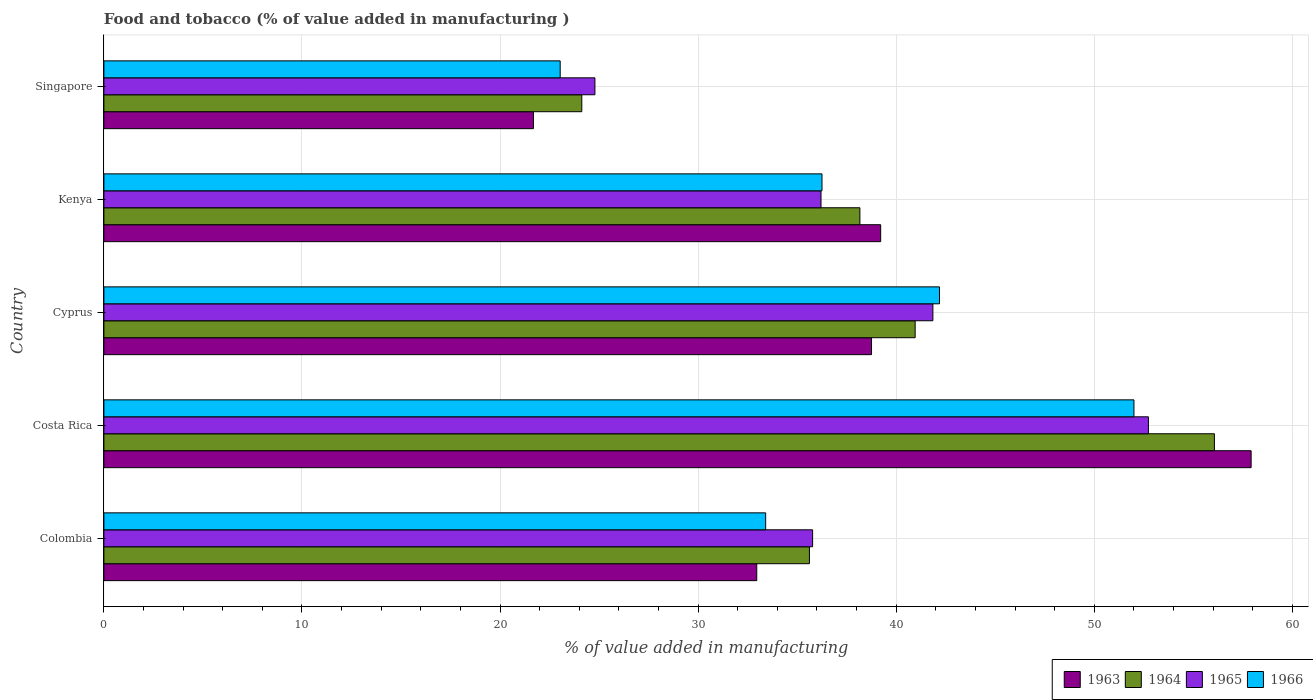How many bars are there on the 1st tick from the bottom?
Make the answer very short. 4. What is the label of the 2nd group of bars from the top?
Offer a terse response. Kenya. What is the value added in manufacturing food and tobacco in 1963 in Costa Rica?
Provide a succinct answer. 57.92. Across all countries, what is the maximum value added in manufacturing food and tobacco in 1964?
Provide a succinct answer. 56.07. Across all countries, what is the minimum value added in manufacturing food and tobacco in 1964?
Offer a very short reply. 24.13. In which country was the value added in manufacturing food and tobacco in 1963 minimum?
Your response must be concise. Singapore. What is the total value added in manufacturing food and tobacco in 1966 in the graph?
Ensure brevity in your answer.  186.89. What is the difference between the value added in manufacturing food and tobacco in 1963 in Cyprus and that in Kenya?
Provide a succinct answer. -0.46. What is the difference between the value added in manufacturing food and tobacco in 1966 in Colombia and the value added in manufacturing food and tobacco in 1963 in Kenya?
Provide a short and direct response. -5.81. What is the average value added in manufacturing food and tobacco in 1966 per country?
Provide a short and direct response. 37.38. What is the difference between the value added in manufacturing food and tobacco in 1966 and value added in manufacturing food and tobacco in 1965 in Colombia?
Offer a terse response. -2.37. What is the ratio of the value added in manufacturing food and tobacco in 1965 in Colombia to that in Singapore?
Your answer should be compact. 1.44. Is the value added in manufacturing food and tobacco in 1965 in Costa Rica less than that in Singapore?
Ensure brevity in your answer.  No. Is the difference between the value added in manufacturing food and tobacco in 1966 in Colombia and Kenya greater than the difference between the value added in manufacturing food and tobacco in 1965 in Colombia and Kenya?
Keep it short and to the point. No. What is the difference between the highest and the second highest value added in manufacturing food and tobacco in 1964?
Provide a succinct answer. 15.11. What is the difference between the highest and the lowest value added in manufacturing food and tobacco in 1963?
Offer a terse response. 36.23. In how many countries, is the value added in manufacturing food and tobacco in 1964 greater than the average value added in manufacturing food and tobacco in 1964 taken over all countries?
Your answer should be very brief. 2. Is the sum of the value added in manufacturing food and tobacco in 1963 in Colombia and Costa Rica greater than the maximum value added in manufacturing food and tobacco in 1964 across all countries?
Give a very brief answer. Yes. What does the 1st bar from the top in Colombia represents?
Make the answer very short. 1966. What does the 4th bar from the bottom in Kenya represents?
Offer a very short reply. 1966. Is it the case that in every country, the sum of the value added in manufacturing food and tobacco in 1965 and value added in manufacturing food and tobacco in 1966 is greater than the value added in manufacturing food and tobacco in 1963?
Keep it short and to the point. Yes. How many countries are there in the graph?
Ensure brevity in your answer.  5. What is the difference between two consecutive major ticks on the X-axis?
Offer a terse response. 10. Are the values on the major ticks of X-axis written in scientific E-notation?
Make the answer very short. No. Where does the legend appear in the graph?
Offer a terse response. Bottom right. How are the legend labels stacked?
Offer a very short reply. Horizontal. What is the title of the graph?
Keep it short and to the point. Food and tobacco (% of value added in manufacturing ). Does "1986" appear as one of the legend labels in the graph?
Provide a succinct answer. No. What is the label or title of the X-axis?
Your answer should be very brief. % of value added in manufacturing. What is the % of value added in manufacturing of 1963 in Colombia?
Make the answer very short. 32.96. What is the % of value added in manufacturing in 1964 in Colombia?
Provide a short and direct response. 35.62. What is the % of value added in manufacturing in 1965 in Colombia?
Your answer should be compact. 35.78. What is the % of value added in manufacturing in 1966 in Colombia?
Keep it short and to the point. 33.41. What is the % of value added in manufacturing in 1963 in Costa Rica?
Your response must be concise. 57.92. What is the % of value added in manufacturing of 1964 in Costa Rica?
Keep it short and to the point. 56.07. What is the % of value added in manufacturing in 1965 in Costa Rica?
Offer a very short reply. 52.73. What is the % of value added in manufacturing in 1966 in Costa Rica?
Keep it short and to the point. 52. What is the % of value added in manufacturing in 1963 in Cyprus?
Offer a terse response. 38.75. What is the % of value added in manufacturing in 1964 in Cyprus?
Your answer should be very brief. 40.96. What is the % of value added in manufacturing of 1965 in Cyprus?
Give a very brief answer. 41.85. What is the % of value added in manufacturing in 1966 in Cyprus?
Offer a very short reply. 42.19. What is the % of value added in manufacturing in 1963 in Kenya?
Offer a very short reply. 39.22. What is the % of value added in manufacturing of 1964 in Kenya?
Give a very brief answer. 38.17. What is the % of value added in manufacturing of 1965 in Kenya?
Ensure brevity in your answer.  36.2. What is the % of value added in manufacturing in 1966 in Kenya?
Keep it short and to the point. 36.25. What is the % of value added in manufacturing in 1963 in Singapore?
Offer a terse response. 21.69. What is the % of value added in manufacturing in 1964 in Singapore?
Your answer should be very brief. 24.13. What is the % of value added in manufacturing of 1965 in Singapore?
Give a very brief answer. 24.79. What is the % of value added in manufacturing of 1966 in Singapore?
Provide a succinct answer. 23.04. Across all countries, what is the maximum % of value added in manufacturing of 1963?
Your response must be concise. 57.92. Across all countries, what is the maximum % of value added in manufacturing in 1964?
Offer a very short reply. 56.07. Across all countries, what is the maximum % of value added in manufacturing of 1965?
Offer a very short reply. 52.73. Across all countries, what is the maximum % of value added in manufacturing in 1966?
Provide a short and direct response. 52. Across all countries, what is the minimum % of value added in manufacturing of 1963?
Give a very brief answer. 21.69. Across all countries, what is the minimum % of value added in manufacturing in 1964?
Give a very brief answer. 24.13. Across all countries, what is the minimum % of value added in manufacturing in 1965?
Your response must be concise. 24.79. Across all countries, what is the minimum % of value added in manufacturing in 1966?
Ensure brevity in your answer.  23.04. What is the total % of value added in manufacturing in 1963 in the graph?
Your answer should be compact. 190.54. What is the total % of value added in manufacturing in 1964 in the graph?
Your response must be concise. 194.94. What is the total % of value added in manufacturing of 1965 in the graph?
Offer a very short reply. 191.36. What is the total % of value added in manufacturing in 1966 in the graph?
Ensure brevity in your answer.  186.89. What is the difference between the % of value added in manufacturing of 1963 in Colombia and that in Costa Rica?
Ensure brevity in your answer.  -24.96. What is the difference between the % of value added in manufacturing in 1964 in Colombia and that in Costa Rica?
Make the answer very short. -20.45. What is the difference between the % of value added in manufacturing in 1965 in Colombia and that in Costa Rica?
Offer a terse response. -16.95. What is the difference between the % of value added in manufacturing in 1966 in Colombia and that in Costa Rica?
Your response must be concise. -18.59. What is the difference between the % of value added in manufacturing in 1963 in Colombia and that in Cyprus?
Your response must be concise. -5.79. What is the difference between the % of value added in manufacturing of 1964 in Colombia and that in Cyprus?
Keep it short and to the point. -5.34. What is the difference between the % of value added in manufacturing of 1965 in Colombia and that in Cyprus?
Provide a short and direct response. -6.07. What is the difference between the % of value added in manufacturing in 1966 in Colombia and that in Cyprus?
Give a very brief answer. -8.78. What is the difference between the % of value added in manufacturing of 1963 in Colombia and that in Kenya?
Give a very brief answer. -6.26. What is the difference between the % of value added in manufacturing of 1964 in Colombia and that in Kenya?
Make the answer very short. -2.55. What is the difference between the % of value added in manufacturing in 1965 in Colombia and that in Kenya?
Give a very brief answer. -0.42. What is the difference between the % of value added in manufacturing in 1966 in Colombia and that in Kenya?
Provide a succinct answer. -2.84. What is the difference between the % of value added in manufacturing of 1963 in Colombia and that in Singapore?
Provide a succinct answer. 11.27. What is the difference between the % of value added in manufacturing of 1964 in Colombia and that in Singapore?
Make the answer very short. 11.49. What is the difference between the % of value added in manufacturing in 1965 in Colombia and that in Singapore?
Provide a succinct answer. 10.99. What is the difference between the % of value added in manufacturing in 1966 in Colombia and that in Singapore?
Your response must be concise. 10.37. What is the difference between the % of value added in manufacturing of 1963 in Costa Rica and that in Cyprus?
Offer a very short reply. 19.17. What is the difference between the % of value added in manufacturing of 1964 in Costa Rica and that in Cyprus?
Give a very brief answer. 15.11. What is the difference between the % of value added in manufacturing in 1965 in Costa Rica and that in Cyprus?
Give a very brief answer. 10.88. What is the difference between the % of value added in manufacturing of 1966 in Costa Rica and that in Cyprus?
Provide a short and direct response. 9.82. What is the difference between the % of value added in manufacturing of 1963 in Costa Rica and that in Kenya?
Your response must be concise. 18.7. What is the difference between the % of value added in manufacturing of 1964 in Costa Rica and that in Kenya?
Your response must be concise. 17.9. What is the difference between the % of value added in manufacturing of 1965 in Costa Rica and that in Kenya?
Offer a terse response. 16.53. What is the difference between the % of value added in manufacturing in 1966 in Costa Rica and that in Kenya?
Keep it short and to the point. 15.75. What is the difference between the % of value added in manufacturing in 1963 in Costa Rica and that in Singapore?
Your answer should be compact. 36.23. What is the difference between the % of value added in manufacturing of 1964 in Costa Rica and that in Singapore?
Make the answer very short. 31.94. What is the difference between the % of value added in manufacturing of 1965 in Costa Rica and that in Singapore?
Your answer should be very brief. 27.94. What is the difference between the % of value added in manufacturing in 1966 in Costa Rica and that in Singapore?
Make the answer very short. 28.97. What is the difference between the % of value added in manufacturing in 1963 in Cyprus and that in Kenya?
Your response must be concise. -0.46. What is the difference between the % of value added in manufacturing of 1964 in Cyprus and that in Kenya?
Your answer should be very brief. 2.79. What is the difference between the % of value added in manufacturing of 1965 in Cyprus and that in Kenya?
Give a very brief answer. 5.65. What is the difference between the % of value added in manufacturing in 1966 in Cyprus and that in Kenya?
Make the answer very short. 5.93. What is the difference between the % of value added in manufacturing of 1963 in Cyprus and that in Singapore?
Ensure brevity in your answer.  17.07. What is the difference between the % of value added in manufacturing of 1964 in Cyprus and that in Singapore?
Offer a very short reply. 16.83. What is the difference between the % of value added in manufacturing of 1965 in Cyprus and that in Singapore?
Offer a terse response. 17.06. What is the difference between the % of value added in manufacturing in 1966 in Cyprus and that in Singapore?
Your answer should be very brief. 19.15. What is the difference between the % of value added in manufacturing of 1963 in Kenya and that in Singapore?
Ensure brevity in your answer.  17.53. What is the difference between the % of value added in manufacturing of 1964 in Kenya and that in Singapore?
Give a very brief answer. 14.04. What is the difference between the % of value added in manufacturing in 1965 in Kenya and that in Singapore?
Ensure brevity in your answer.  11.41. What is the difference between the % of value added in manufacturing in 1966 in Kenya and that in Singapore?
Provide a short and direct response. 13.22. What is the difference between the % of value added in manufacturing of 1963 in Colombia and the % of value added in manufacturing of 1964 in Costa Rica?
Offer a very short reply. -23.11. What is the difference between the % of value added in manufacturing of 1963 in Colombia and the % of value added in manufacturing of 1965 in Costa Rica?
Your answer should be very brief. -19.77. What is the difference between the % of value added in manufacturing of 1963 in Colombia and the % of value added in manufacturing of 1966 in Costa Rica?
Provide a short and direct response. -19.04. What is the difference between the % of value added in manufacturing of 1964 in Colombia and the % of value added in manufacturing of 1965 in Costa Rica?
Your response must be concise. -17.11. What is the difference between the % of value added in manufacturing in 1964 in Colombia and the % of value added in manufacturing in 1966 in Costa Rica?
Keep it short and to the point. -16.38. What is the difference between the % of value added in manufacturing of 1965 in Colombia and the % of value added in manufacturing of 1966 in Costa Rica?
Provide a succinct answer. -16.22. What is the difference between the % of value added in manufacturing in 1963 in Colombia and the % of value added in manufacturing in 1964 in Cyprus?
Provide a succinct answer. -8. What is the difference between the % of value added in manufacturing of 1963 in Colombia and the % of value added in manufacturing of 1965 in Cyprus?
Provide a succinct answer. -8.89. What is the difference between the % of value added in manufacturing in 1963 in Colombia and the % of value added in manufacturing in 1966 in Cyprus?
Ensure brevity in your answer.  -9.23. What is the difference between the % of value added in manufacturing in 1964 in Colombia and the % of value added in manufacturing in 1965 in Cyprus?
Your answer should be compact. -6.23. What is the difference between the % of value added in manufacturing in 1964 in Colombia and the % of value added in manufacturing in 1966 in Cyprus?
Offer a terse response. -6.57. What is the difference between the % of value added in manufacturing in 1965 in Colombia and the % of value added in manufacturing in 1966 in Cyprus?
Your answer should be very brief. -6.41. What is the difference between the % of value added in manufacturing of 1963 in Colombia and the % of value added in manufacturing of 1964 in Kenya?
Your answer should be very brief. -5.21. What is the difference between the % of value added in manufacturing of 1963 in Colombia and the % of value added in manufacturing of 1965 in Kenya?
Ensure brevity in your answer.  -3.24. What is the difference between the % of value added in manufacturing in 1963 in Colombia and the % of value added in manufacturing in 1966 in Kenya?
Keep it short and to the point. -3.29. What is the difference between the % of value added in manufacturing in 1964 in Colombia and the % of value added in manufacturing in 1965 in Kenya?
Your response must be concise. -0.58. What is the difference between the % of value added in manufacturing in 1964 in Colombia and the % of value added in manufacturing in 1966 in Kenya?
Offer a very short reply. -0.63. What is the difference between the % of value added in manufacturing in 1965 in Colombia and the % of value added in manufacturing in 1966 in Kenya?
Your answer should be very brief. -0.47. What is the difference between the % of value added in manufacturing of 1963 in Colombia and the % of value added in manufacturing of 1964 in Singapore?
Offer a very short reply. 8.83. What is the difference between the % of value added in manufacturing of 1963 in Colombia and the % of value added in manufacturing of 1965 in Singapore?
Offer a terse response. 8.17. What is the difference between the % of value added in manufacturing in 1963 in Colombia and the % of value added in manufacturing in 1966 in Singapore?
Offer a very short reply. 9.92. What is the difference between the % of value added in manufacturing in 1964 in Colombia and the % of value added in manufacturing in 1965 in Singapore?
Provide a succinct answer. 10.83. What is the difference between the % of value added in manufacturing in 1964 in Colombia and the % of value added in manufacturing in 1966 in Singapore?
Keep it short and to the point. 12.58. What is the difference between the % of value added in manufacturing of 1965 in Colombia and the % of value added in manufacturing of 1966 in Singapore?
Give a very brief answer. 12.74. What is the difference between the % of value added in manufacturing in 1963 in Costa Rica and the % of value added in manufacturing in 1964 in Cyprus?
Ensure brevity in your answer.  16.96. What is the difference between the % of value added in manufacturing of 1963 in Costa Rica and the % of value added in manufacturing of 1965 in Cyprus?
Ensure brevity in your answer.  16.07. What is the difference between the % of value added in manufacturing of 1963 in Costa Rica and the % of value added in manufacturing of 1966 in Cyprus?
Provide a short and direct response. 15.73. What is the difference between the % of value added in manufacturing in 1964 in Costa Rica and the % of value added in manufacturing in 1965 in Cyprus?
Your answer should be very brief. 14.21. What is the difference between the % of value added in manufacturing in 1964 in Costa Rica and the % of value added in manufacturing in 1966 in Cyprus?
Offer a very short reply. 13.88. What is the difference between the % of value added in manufacturing of 1965 in Costa Rica and the % of value added in manufacturing of 1966 in Cyprus?
Provide a succinct answer. 10.55. What is the difference between the % of value added in manufacturing of 1963 in Costa Rica and the % of value added in manufacturing of 1964 in Kenya?
Provide a short and direct response. 19.75. What is the difference between the % of value added in manufacturing in 1963 in Costa Rica and the % of value added in manufacturing in 1965 in Kenya?
Your answer should be compact. 21.72. What is the difference between the % of value added in manufacturing of 1963 in Costa Rica and the % of value added in manufacturing of 1966 in Kenya?
Your response must be concise. 21.67. What is the difference between the % of value added in manufacturing of 1964 in Costa Rica and the % of value added in manufacturing of 1965 in Kenya?
Keep it short and to the point. 19.86. What is the difference between the % of value added in manufacturing of 1964 in Costa Rica and the % of value added in manufacturing of 1966 in Kenya?
Offer a very short reply. 19.81. What is the difference between the % of value added in manufacturing of 1965 in Costa Rica and the % of value added in manufacturing of 1966 in Kenya?
Your answer should be compact. 16.48. What is the difference between the % of value added in manufacturing of 1963 in Costa Rica and the % of value added in manufacturing of 1964 in Singapore?
Offer a very short reply. 33.79. What is the difference between the % of value added in manufacturing in 1963 in Costa Rica and the % of value added in manufacturing in 1965 in Singapore?
Provide a short and direct response. 33.13. What is the difference between the % of value added in manufacturing of 1963 in Costa Rica and the % of value added in manufacturing of 1966 in Singapore?
Make the answer very short. 34.88. What is the difference between the % of value added in manufacturing in 1964 in Costa Rica and the % of value added in manufacturing in 1965 in Singapore?
Keep it short and to the point. 31.28. What is the difference between the % of value added in manufacturing in 1964 in Costa Rica and the % of value added in manufacturing in 1966 in Singapore?
Your answer should be very brief. 33.03. What is the difference between the % of value added in manufacturing of 1965 in Costa Rica and the % of value added in manufacturing of 1966 in Singapore?
Provide a succinct answer. 29.7. What is the difference between the % of value added in manufacturing of 1963 in Cyprus and the % of value added in manufacturing of 1964 in Kenya?
Your answer should be compact. 0.59. What is the difference between the % of value added in manufacturing in 1963 in Cyprus and the % of value added in manufacturing in 1965 in Kenya?
Make the answer very short. 2.55. What is the difference between the % of value added in manufacturing in 1963 in Cyprus and the % of value added in manufacturing in 1966 in Kenya?
Keep it short and to the point. 2.5. What is the difference between the % of value added in manufacturing of 1964 in Cyprus and the % of value added in manufacturing of 1965 in Kenya?
Make the answer very short. 4.75. What is the difference between the % of value added in manufacturing of 1964 in Cyprus and the % of value added in manufacturing of 1966 in Kenya?
Give a very brief answer. 4.7. What is the difference between the % of value added in manufacturing in 1965 in Cyprus and the % of value added in manufacturing in 1966 in Kenya?
Offer a terse response. 5.6. What is the difference between the % of value added in manufacturing in 1963 in Cyprus and the % of value added in manufacturing in 1964 in Singapore?
Give a very brief answer. 14.63. What is the difference between the % of value added in manufacturing of 1963 in Cyprus and the % of value added in manufacturing of 1965 in Singapore?
Provide a succinct answer. 13.96. What is the difference between the % of value added in manufacturing of 1963 in Cyprus and the % of value added in manufacturing of 1966 in Singapore?
Make the answer very short. 15.72. What is the difference between the % of value added in manufacturing in 1964 in Cyprus and the % of value added in manufacturing in 1965 in Singapore?
Your answer should be very brief. 16.17. What is the difference between the % of value added in manufacturing of 1964 in Cyprus and the % of value added in manufacturing of 1966 in Singapore?
Make the answer very short. 17.92. What is the difference between the % of value added in manufacturing of 1965 in Cyprus and the % of value added in manufacturing of 1966 in Singapore?
Give a very brief answer. 18.82. What is the difference between the % of value added in manufacturing of 1963 in Kenya and the % of value added in manufacturing of 1964 in Singapore?
Provide a succinct answer. 15.09. What is the difference between the % of value added in manufacturing in 1963 in Kenya and the % of value added in manufacturing in 1965 in Singapore?
Your answer should be compact. 14.43. What is the difference between the % of value added in manufacturing in 1963 in Kenya and the % of value added in manufacturing in 1966 in Singapore?
Your response must be concise. 16.18. What is the difference between the % of value added in manufacturing of 1964 in Kenya and the % of value added in manufacturing of 1965 in Singapore?
Keep it short and to the point. 13.38. What is the difference between the % of value added in manufacturing in 1964 in Kenya and the % of value added in manufacturing in 1966 in Singapore?
Provide a short and direct response. 15.13. What is the difference between the % of value added in manufacturing of 1965 in Kenya and the % of value added in manufacturing of 1966 in Singapore?
Your answer should be compact. 13.17. What is the average % of value added in manufacturing in 1963 per country?
Provide a short and direct response. 38.11. What is the average % of value added in manufacturing in 1964 per country?
Your answer should be very brief. 38.99. What is the average % of value added in manufacturing of 1965 per country?
Make the answer very short. 38.27. What is the average % of value added in manufacturing of 1966 per country?
Provide a short and direct response. 37.38. What is the difference between the % of value added in manufacturing of 1963 and % of value added in manufacturing of 1964 in Colombia?
Offer a terse response. -2.66. What is the difference between the % of value added in manufacturing in 1963 and % of value added in manufacturing in 1965 in Colombia?
Your answer should be very brief. -2.82. What is the difference between the % of value added in manufacturing in 1963 and % of value added in manufacturing in 1966 in Colombia?
Give a very brief answer. -0.45. What is the difference between the % of value added in manufacturing in 1964 and % of value added in manufacturing in 1965 in Colombia?
Your response must be concise. -0.16. What is the difference between the % of value added in manufacturing in 1964 and % of value added in manufacturing in 1966 in Colombia?
Your response must be concise. 2.21. What is the difference between the % of value added in manufacturing of 1965 and % of value added in manufacturing of 1966 in Colombia?
Provide a short and direct response. 2.37. What is the difference between the % of value added in manufacturing in 1963 and % of value added in manufacturing in 1964 in Costa Rica?
Ensure brevity in your answer.  1.85. What is the difference between the % of value added in manufacturing of 1963 and % of value added in manufacturing of 1965 in Costa Rica?
Your answer should be compact. 5.19. What is the difference between the % of value added in manufacturing in 1963 and % of value added in manufacturing in 1966 in Costa Rica?
Your response must be concise. 5.92. What is the difference between the % of value added in manufacturing of 1964 and % of value added in manufacturing of 1965 in Costa Rica?
Your answer should be very brief. 3.33. What is the difference between the % of value added in manufacturing of 1964 and % of value added in manufacturing of 1966 in Costa Rica?
Your response must be concise. 4.06. What is the difference between the % of value added in manufacturing of 1965 and % of value added in manufacturing of 1966 in Costa Rica?
Offer a terse response. 0.73. What is the difference between the % of value added in manufacturing in 1963 and % of value added in manufacturing in 1964 in Cyprus?
Make the answer very short. -2.2. What is the difference between the % of value added in manufacturing of 1963 and % of value added in manufacturing of 1965 in Cyprus?
Give a very brief answer. -3.1. What is the difference between the % of value added in manufacturing of 1963 and % of value added in manufacturing of 1966 in Cyprus?
Ensure brevity in your answer.  -3.43. What is the difference between the % of value added in manufacturing of 1964 and % of value added in manufacturing of 1965 in Cyprus?
Make the answer very short. -0.9. What is the difference between the % of value added in manufacturing of 1964 and % of value added in manufacturing of 1966 in Cyprus?
Make the answer very short. -1.23. What is the difference between the % of value added in manufacturing in 1965 and % of value added in manufacturing in 1966 in Cyprus?
Keep it short and to the point. -0.33. What is the difference between the % of value added in manufacturing of 1963 and % of value added in manufacturing of 1964 in Kenya?
Keep it short and to the point. 1.05. What is the difference between the % of value added in manufacturing of 1963 and % of value added in manufacturing of 1965 in Kenya?
Provide a short and direct response. 3.01. What is the difference between the % of value added in manufacturing in 1963 and % of value added in manufacturing in 1966 in Kenya?
Offer a very short reply. 2.96. What is the difference between the % of value added in manufacturing in 1964 and % of value added in manufacturing in 1965 in Kenya?
Keep it short and to the point. 1.96. What is the difference between the % of value added in manufacturing of 1964 and % of value added in manufacturing of 1966 in Kenya?
Offer a very short reply. 1.91. What is the difference between the % of value added in manufacturing in 1963 and % of value added in manufacturing in 1964 in Singapore?
Your answer should be compact. -2.44. What is the difference between the % of value added in manufacturing of 1963 and % of value added in manufacturing of 1965 in Singapore?
Your answer should be very brief. -3.1. What is the difference between the % of value added in manufacturing of 1963 and % of value added in manufacturing of 1966 in Singapore?
Offer a terse response. -1.35. What is the difference between the % of value added in manufacturing in 1964 and % of value added in manufacturing in 1965 in Singapore?
Make the answer very short. -0.66. What is the difference between the % of value added in manufacturing of 1964 and % of value added in manufacturing of 1966 in Singapore?
Offer a very short reply. 1.09. What is the difference between the % of value added in manufacturing of 1965 and % of value added in manufacturing of 1966 in Singapore?
Your response must be concise. 1.75. What is the ratio of the % of value added in manufacturing in 1963 in Colombia to that in Costa Rica?
Offer a very short reply. 0.57. What is the ratio of the % of value added in manufacturing of 1964 in Colombia to that in Costa Rica?
Your response must be concise. 0.64. What is the ratio of the % of value added in manufacturing in 1965 in Colombia to that in Costa Rica?
Offer a terse response. 0.68. What is the ratio of the % of value added in manufacturing of 1966 in Colombia to that in Costa Rica?
Make the answer very short. 0.64. What is the ratio of the % of value added in manufacturing in 1963 in Colombia to that in Cyprus?
Provide a short and direct response. 0.85. What is the ratio of the % of value added in manufacturing in 1964 in Colombia to that in Cyprus?
Provide a short and direct response. 0.87. What is the ratio of the % of value added in manufacturing in 1965 in Colombia to that in Cyprus?
Offer a very short reply. 0.85. What is the ratio of the % of value added in manufacturing of 1966 in Colombia to that in Cyprus?
Offer a terse response. 0.79. What is the ratio of the % of value added in manufacturing of 1963 in Colombia to that in Kenya?
Keep it short and to the point. 0.84. What is the ratio of the % of value added in manufacturing in 1964 in Colombia to that in Kenya?
Provide a short and direct response. 0.93. What is the ratio of the % of value added in manufacturing in 1965 in Colombia to that in Kenya?
Your answer should be very brief. 0.99. What is the ratio of the % of value added in manufacturing of 1966 in Colombia to that in Kenya?
Your response must be concise. 0.92. What is the ratio of the % of value added in manufacturing of 1963 in Colombia to that in Singapore?
Offer a terse response. 1.52. What is the ratio of the % of value added in manufacturing of 1964 in Colombia to that in Singapore?
Ensure brevity in your answer.  1.48. What is the ratio of the % of value added in manufacturing of 1965 in Colombia to that in Singapore?
Offer a terse response. 1.44. What is the ratio of the % of value added in manufacturing of 1966 in Colombia to that in Singapore?
Make the answer very short. 1.45. What is the ratio of the % of value added in manufacturing in 1963 in Costa Rica to that in Cyprus?
Give a very brief answer. 1.49. What is the ratio of the % of value added in manufacturing in 1964 in Costa Rica to that in Cyprus?
Provide a short and direct response. 1.37. What is the ratio of the % of value added in manufacturing in 1965 in Costa Rica to that in Cyprus?
Provide a short and direct response. 1.26. What is the ratio of the % of value added in manufacturing in 1966 in Costa Rica to that in Cyprus?
Keep it short and to the point. 1.23. What is the ratio of the % of value added in manufacturing of 1963 in Costa Rica to that in Kenya?
Your answer should be compact. 1.48. What is the ratio of the % of value added in manufacturing of 1964 in Costa Rica to that in Kenya?
Provide a succinct answer. 1.47. What is the ratio of the % of value added in manufacturing in 1965 in Costa Rica to that in Kenya?
Provide a succinct answer. 1.46. What is the ratio of the % of value added in manufacturing in 1966 in Costa Rica to that in Kenya?
Your answer should be compact. 1.43. What is the ratio of the % of value added in manufacturing in 1963 in Costa Rica to that in Singapore?
Keep it short and to the point. 2.67. What is the ratio of the % of value added in manufacturing of 1964 in Costa Rica to that in Singapore?
Keep it short and to the point. 2.32. What is the ratio of the % of value added in manufacturing of 1965 in Costa Rica to that in Singapore?
Ensure brevity in your answer.  2.13. What is the ratio of the % of value added in manufacturing in 1966 in Costa Rica to that in Singapore?
Ensure brevity in your answer.  2.26. What is the ratio of the % of value added in manufacturing in 1964 in Cyprus to that in Kenya?
Your response must be concise. 1.07. What is the ratio of the % of value added in manufacturing of 1965 in Cyprus to that in Kenya?
Offer a terse response. 1.16. What is the ratio of the % of value added in manufacturing in 1966 in Cyprus to that in Kenya?
Ensure brevity in your answer.  1.16. What is the ratio of the % of value added in manufacturing in 1963 in Cyprus to that in Singapore?
Provide a short and direct response. 1.79. What is the ratio of the % of value added in manufacturing of 1964 in Cyprus to that in Singapore?
Provide a succinct answer. 1.7. What is the ratio of the % of value added in manufacturing in 1965 in Cyprus to that in Singapore?
Your answer should be compact. 1.69. What is the ratio of the % of value added in manufacturing of 1966 in Cyprus to that in Singapore?
Offer a very short reply. 1.83. What is the ratio of the % of value added in manufacturing in 1963 in Kenya to that in Singapore?
Offer a terse response. 1.81. What is the ratio of the % of value added in manufacturing in 1964 in Kenya to that in Singapore?
Give a very brief answer. 1.58. What is the ratio of the % of value added in manufacturing of 1965 in Kenya to that in Singapore?
Your answer should be very brief. 1.46. What is the ratio of the % of value added in manufacturing in 1966 in Kenya to that in Singapore?
Keep it short and to the point. 1.57. What is the difference between the highest and the second highest % of value added in manufacturing in 1963?
Your answer should be very brief. 18.7. What is the difference between the highest and the second highest % of value added in manufacturing of 1964?
Ensure brevity in your answer.  15.11. What is the difference between the highest and the second highest % of value added in manufacturing of 1965?
Offer a very short reply. 10.88. What is the difference between the highest and the second highest % of value added in manufacturing in 1966?
Provide a succinct answer. 9.82. What is the difference between the highest and the lowest % of value added in manufacturing of 1963?
Offer a very short reply. 36.23. What is the difference between the highest and the lowest % of value added in manufacturing of 1964?
Give a very brief answer. 31.94. What is the difference between the highest and the lowest % of value added in manufacturing in 1965?
Your answer should be compact. 27.94. What is the difference between the highest and the lowest % of value added in manufacturing in 1966?
Make the answer very short. 28.97. 